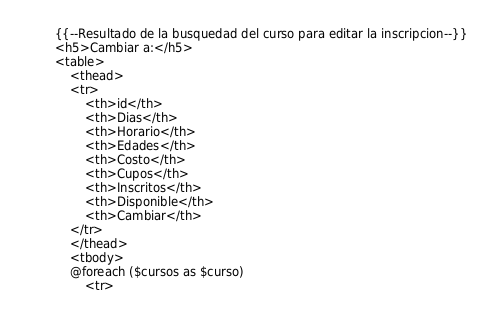Convert code to text. <code><loc_0><loc_0><loc_500><loc_500><_PHP_>{{--Resultado de la busquedad del curso para editar la inscripcion--}}
<h5>Cambiar a:</h5>
<table>
    <thead>
    <tr>
        <th>id</th>
        <th>Dias</th>
        <th>Horario</th>
        <th>Edades</th>
        <th>Costo</th>
        <th>Cupos</th>
        <th>Inscritos</th>
        <th>Disponible</th>
        <th>Cambiar</th>
    </tr>
    </thead>
    <tbody>
    @foreach ($cursos as $curso)
        <tr></code> 